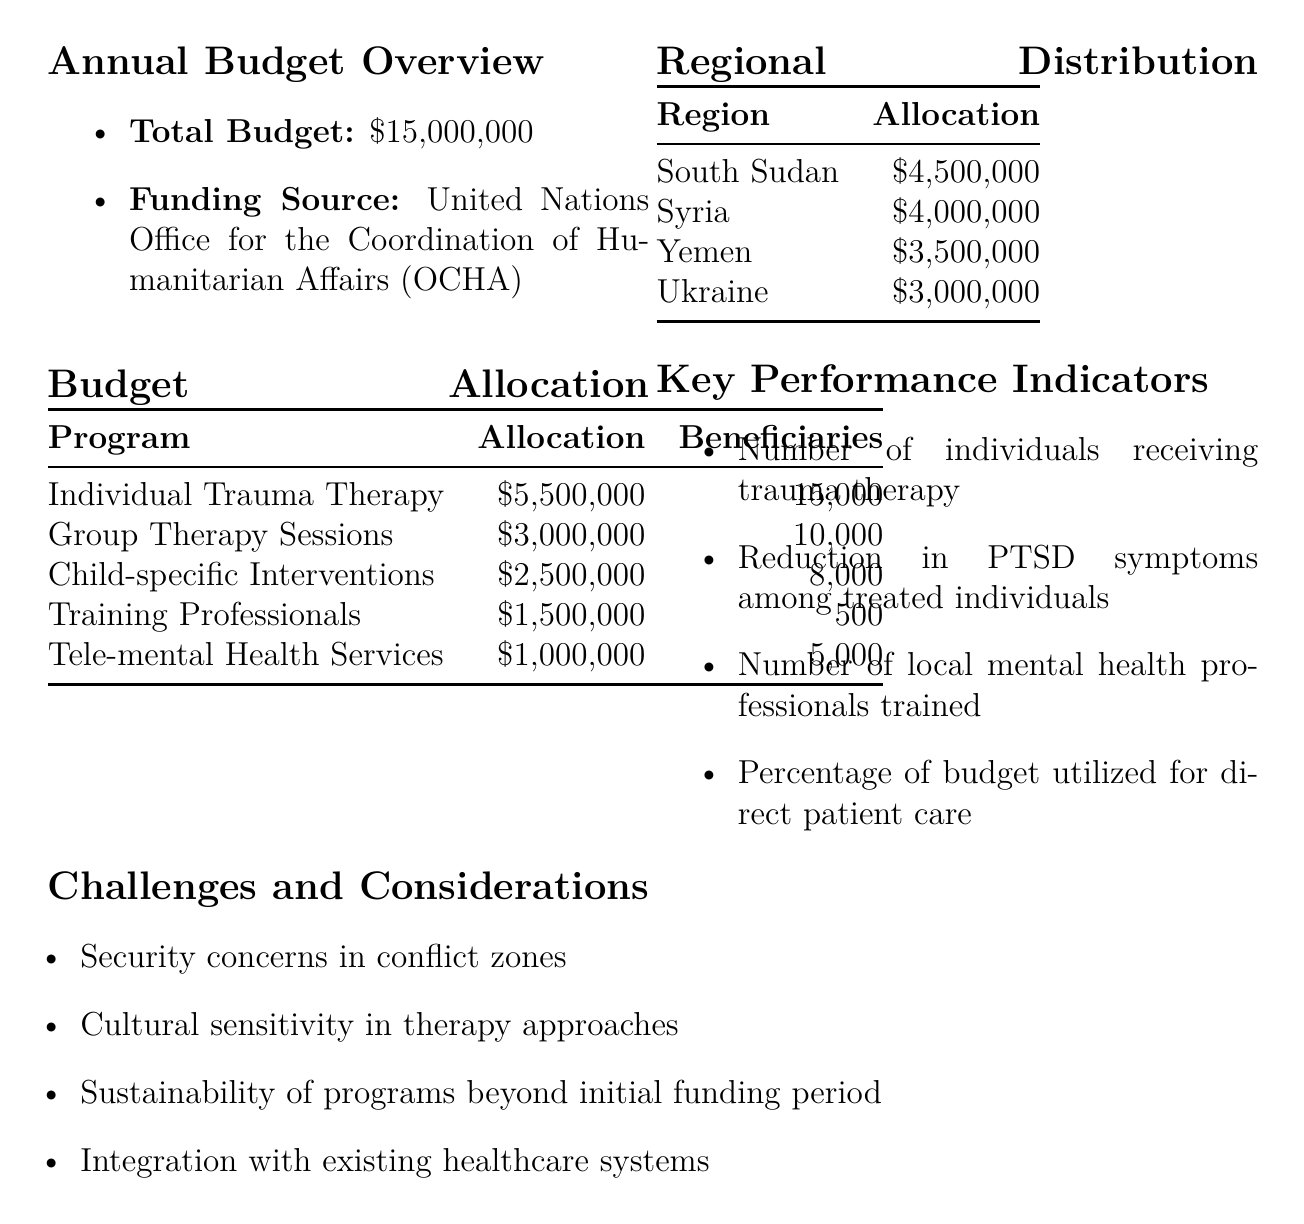What is the total budget for the fiscal year? The total budget is explicitly stated in the document as $15,000,000.
Answer: $15,000,000 How much is allocated for Individual Trauma Therapy? The specific allocation for Individual Trauma Therapy is provided in the budget allocation section, which is $5,500,000.
Answer: $5,500,000 How many beneficiaries are targeted in Group Therapy Sessions? The number of beneficiaries for Group Therapy Sessions is mentioned as 10,000 individuals.
Answer: 10,000 individuals Which region has the highest allocation? The regional distribution section indicates that South Sudan has the highest allocation of $4,500,000.
Answer: South Sudan What is one of the key performance indicators listed? The document lists several key performance indicators; one of them is "Number of individuals receiving trauma therapy."
Answer: Number of individuals receiving trauma therapy What is a challenge mentioned regarding the therapy programs? The document mentions multiple challenges; one is "Security concerns in conflict zones."
Answer: Security concerns in conflict zones How much is allocated for Training Local Mental Health Professionals? The document specifies that $1,500,000 is allocated for training local mental health professionals.
Answer: $1,500,000 What is the total beneficiary count across all programs? The total beneficiaries across all programs can be calculated as 15,000 + 10,000 + 8,000 + 500 + 5,000 = 38,500 individuals.
Answer: 38,500 individuals What type of funding source is mentioned for the budget? The document explicitly states that the funding source is the United Nations Office for the Coordination of Humanitarian Affairs (OCHA).
Answer: United Nations Office for the Coordination of Humanitarian Affairs (OCHA) 